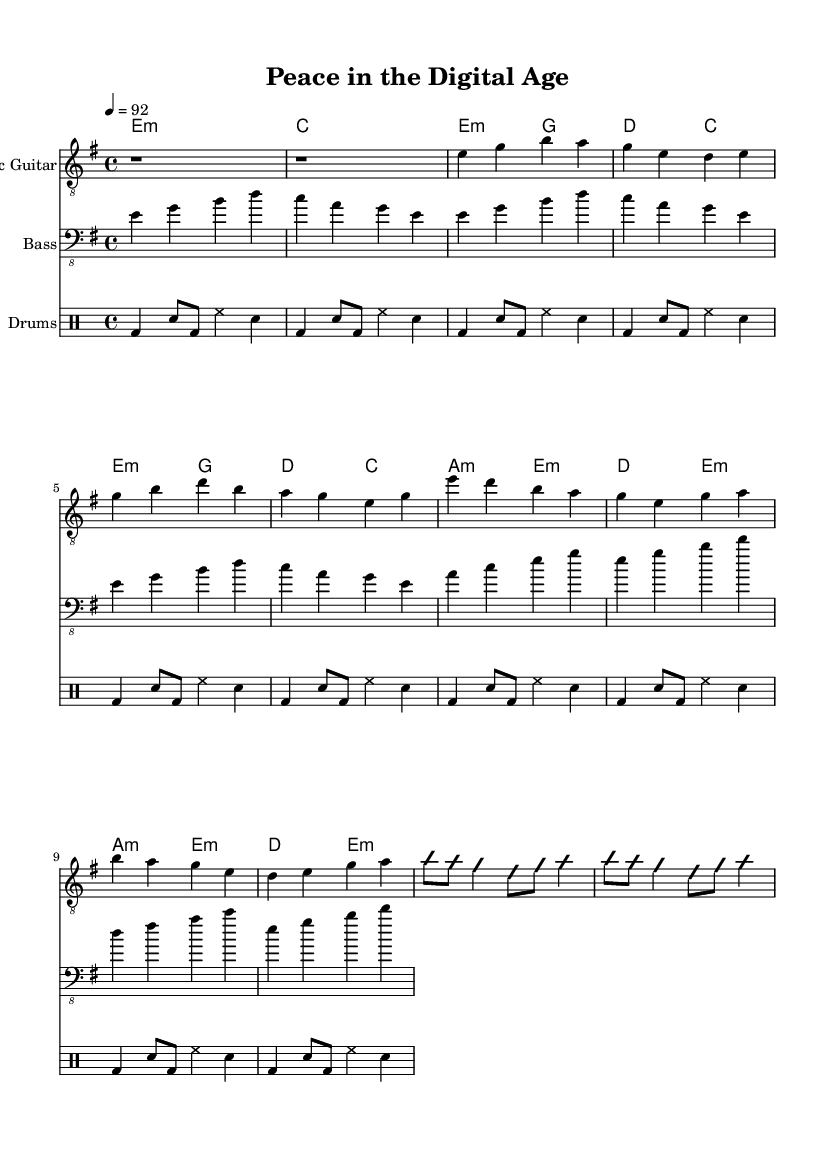What is the key signature of this music? The key signature is E minor, indicated by one sharp (F#) in the key signature section.
Answer: E minor What is the time signature of this music? The time signature is 4/4, which indicates that there are four beats in each measure and the quarter note gets one beat.
Answer: 4/4 What is the tempo marking of this music? The tempo marking is "4 = 92," indicating a moderate tempo of 92 beats per minute, with '4' representing a quarter note.
Answer: 92 How many measures are there in the verse section? The verse section has four measures, each consisting of two lines, which is indicated by the musical notation.
Answer: 4 What style of music is this composition associated with? This composition is associated with electric blues, characterized by its use of electric guitar and distinctive chord progressions typical of the genre.
Answer: Electric blues What chords are played in the chorus section? The chorus consists of the chords A minor, E minor, D major, and E minor, as indicated in the chord progression beneath the notation.
Answer: A minor, E minor, D major, E minor What is the function of the improvisation section in the music? The improvisation section allows the guitarist to express creativity and skill through spontaneous musical ideas, typical in electric blues genres for solos.
Answer: Improvisation 